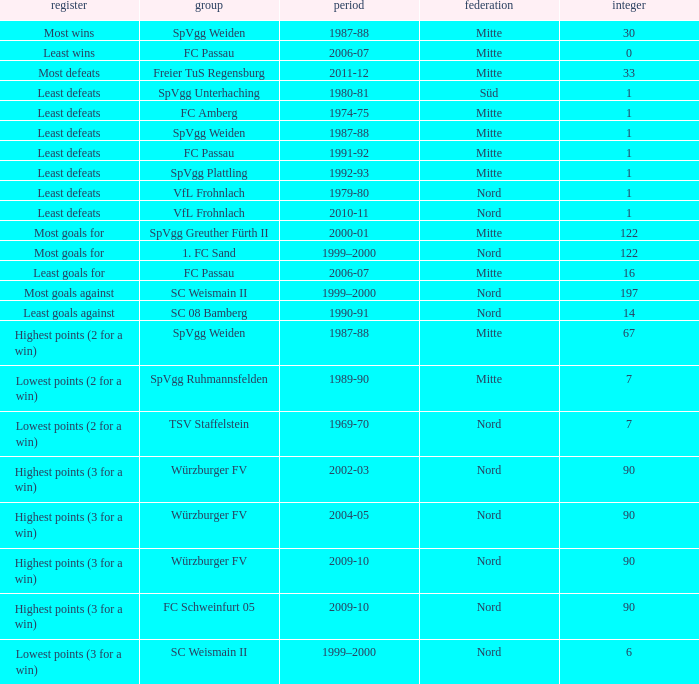What team has 2000-01 as the season? SpVgg Greuther Fürth II. 